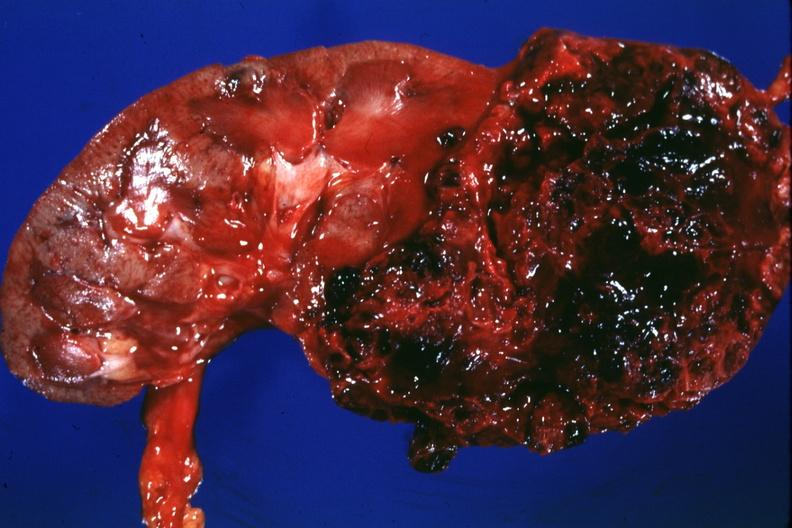what does this image show?
Answer the question using a single word or phrase. Large lesion more hemorrhagic than usual - 